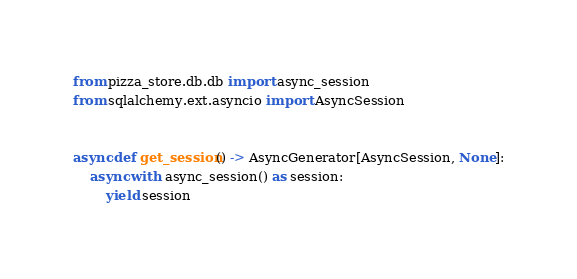Convert code to text. <code><loc_0><loc_0><loc_500><loc_500><_Python_>
from pizza_store.db.db import async_session
from sqlalchemy.ext.asyncio import AsyncSession


async def get_session() -> AsyncGenerator[AsyncSession, None]:
    async with async_session() as session:
        yield session
</code> 